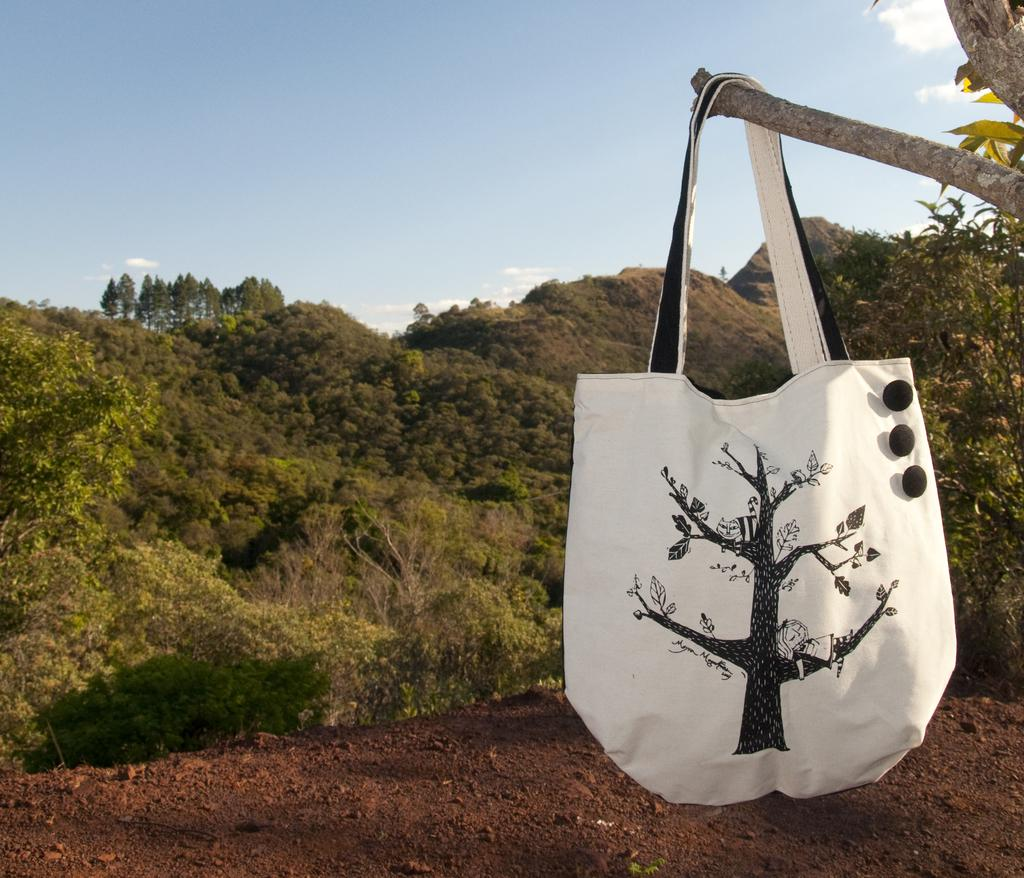What type of handbag can be seen in the image? There is a white handbag in the image. Where is the handbag placed? The handbag is placed on the stem of a tree. What is the condition of the ground in the image? The floor appears to be muddy in the image. What type of environment is depicted in the image? There is greenery visible in the image. Where can the soap and basin be found in the image? There is no soap or basin present in the image. What type of animals can be seen at the zoo in the image? There is no zoo depicted in the image. 